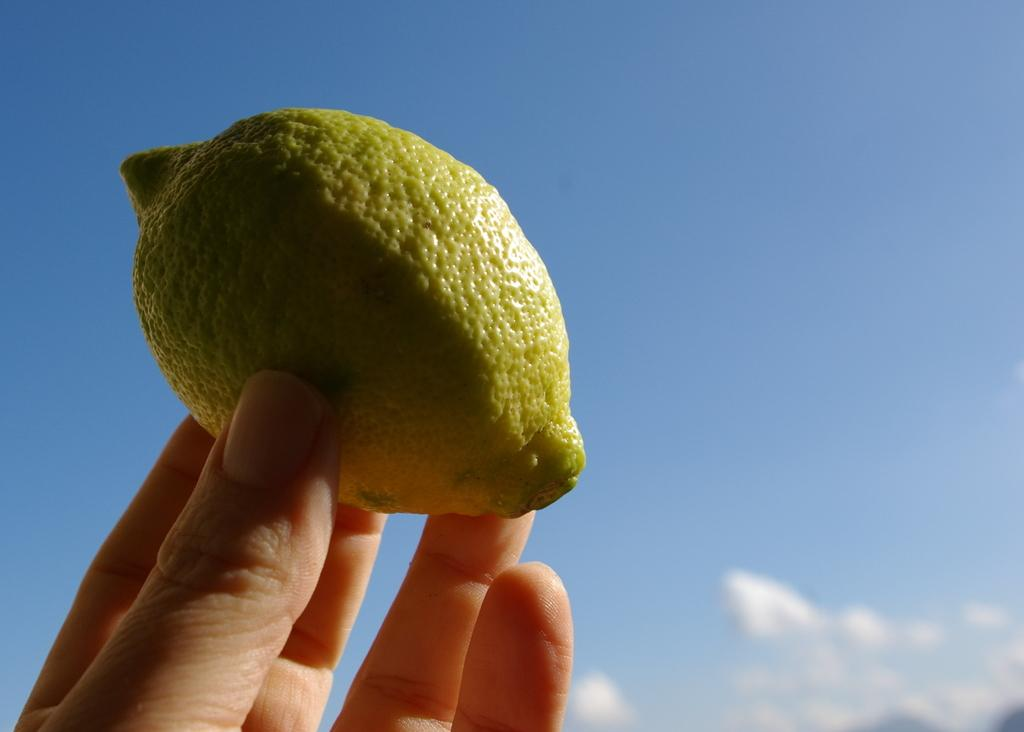Where was the image taken? The image is clicked outside. What can be seen in the foreground of the image? There is a person's hand in the foreground of the image. What is the hand holding? The hand is holding a lemon. What is visible in the background of the image? There is a sky visible in the background of the image. What can be observed about the sky in the image? There are clouds in the sky. What type of pets can be seen playing with a rake in the image? There are no pets or rakes present in the image; it features a person's hand holding a lemon. What kind of coach is visible in the image? There is no coach present in the image. 